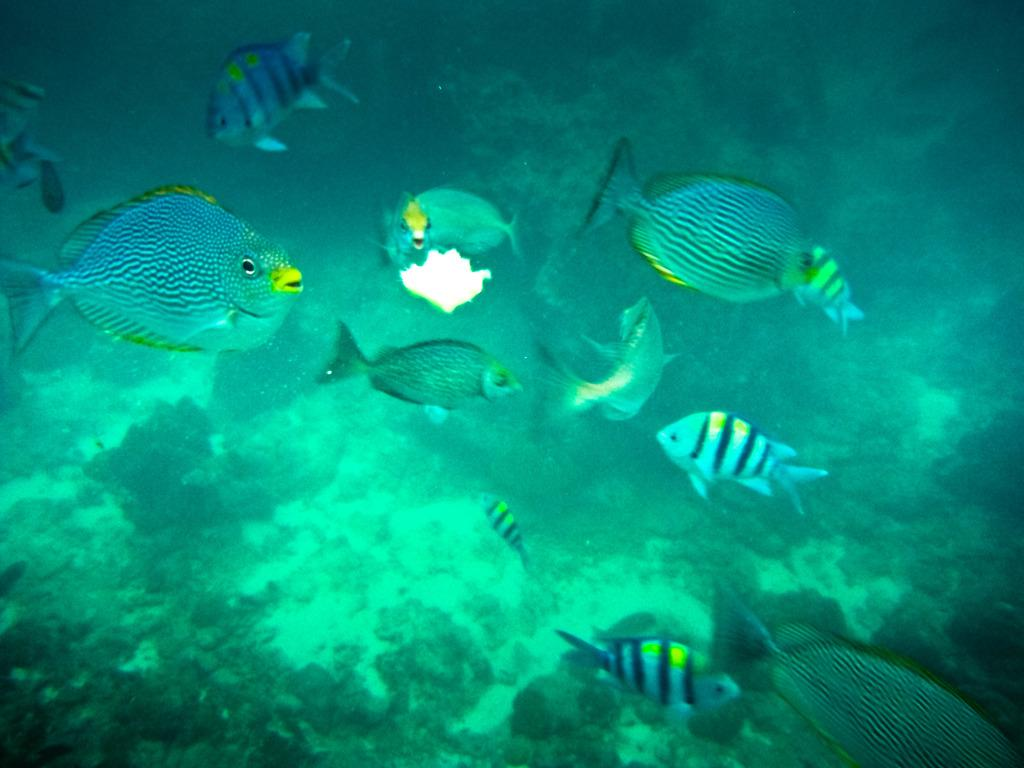What type of animals can be seen in the water in the image? There are fish in the water in the image. Can you describe the positioning of the fish in the image? One fish is truncated towards the bottom of the image, and another fish is truncated towards the left of the image. How many cherries are floating on the water in the image? There are no cherries present in the image; it features fish in the water. What type of card is visible in the image? There are no cards present in the image. 